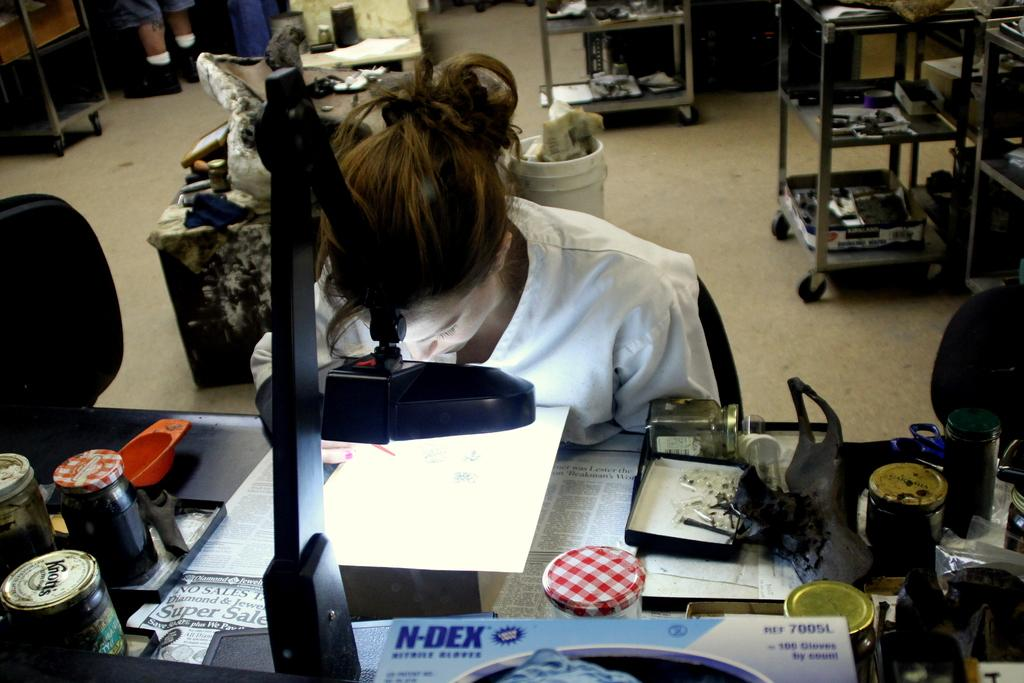<image>
Render a clear and concise summary of the photo. The lab uses the blue N-DEX brand gloves. 